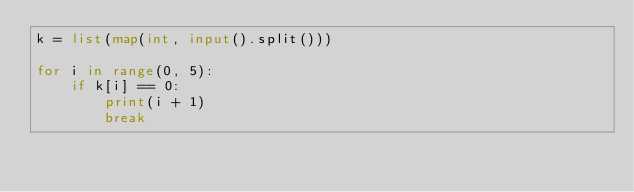Convert code to text. <code><loc_0><loc_0><loc_500><loc_500><_Python_>k = list(map(int, input().split()))

for i in range(0, 5):
    if k[i] == 0:
        print(i + 1)
        break</code> 